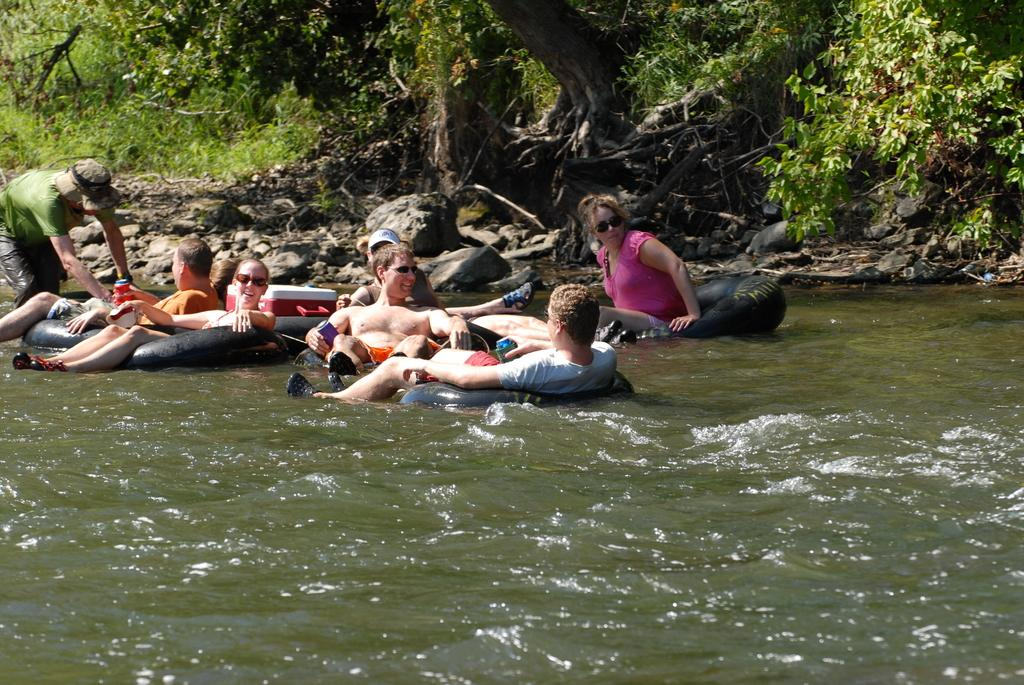What are the persons in the image doing? The persons in the image are in balloons. How are the balloons situated in the image? The balloons are sailing on the water. What can be seen in the background of the image? There are trees, plants, and stones in the background of the image. What type of spark can be seen in the image? There is no spark present in the image. What type of alley can be seen in the image? There is no alley present in the image. 